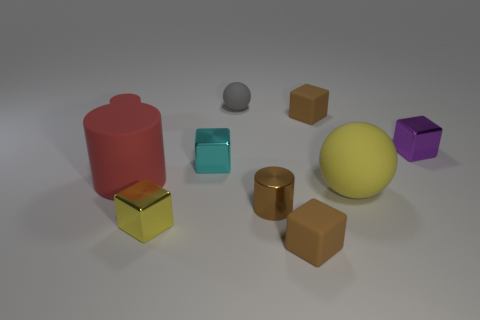Subtract all tiny cylinders. How many cylinders are left? 1 Subtract all brown cylinders. How many cylinders are left? 2 Subtract all spheres. How many objects are left? 8 Subtract 3 cubes. How many cubes are left? 2 Subtract all cyan cubes. How many yellow spheres are left? 1 Subtract all brown matte blocks. Subtract all tiny gray matte things. How many objects are left? 7 Add 1 tiny brown things. How many tiny brown things are left? 4 Add 7 yellow metallic things. How many yellow metallic things exist? 8 Subtract 1 brown cylinders. How many objects are left? 9 Subtract all purple blocks. Subtract all cyan balls. How many blocks are left? 4 